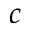Convert formula to latex. <formula><loc_0><loc_0><loc_500><loc_500>c</formula> 